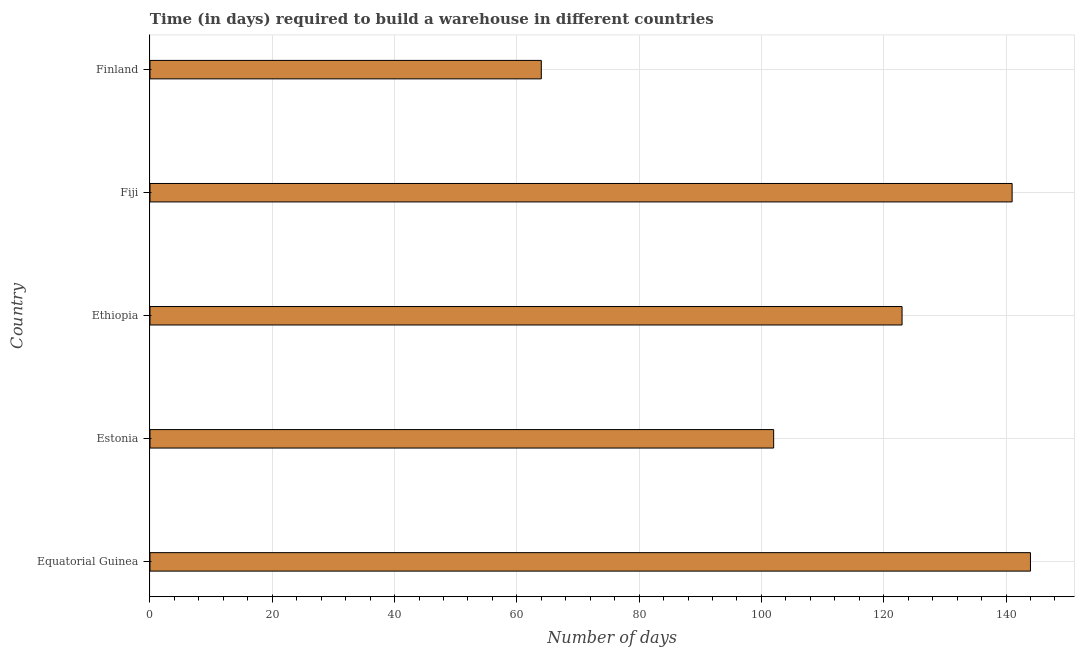Does the graph contain any zero values?
Offer a terse response. No. Does the graph contain grids?
Make the answer very short. Yes. What is the title of the graph?
Keep it short and to the point. Time (in days) required to build a warehouse in different countries. What is the label or title of the X-axis?
Ensure brevity in your answer.  Number of days. What is the label or title of the Y-axis?
Offer a terse response. Country. What is the time required to build a warehouse in Equatorial Guinea?
Offer a terse response. 144. Across all countries, what is the maximum time required to build a warehouse?
Your response must be concise. 144. In which country was the time required to build a warehouse maximum?
Offer a very short reply. Equatorial Guinea. What is the sum of the time required to build a warehouse?
Ensure brevity in your answer.  574. What is the average time required to build a warehouse per country?
Keep it short and to the point. 114.8. What is the median time required to build a warehouse?
Provide a short and direct response. 123. What is the ratio of the time required to build a warehouse in Estonia to that in Fiji?
Keep it short and to the point. 0.72. What is the difference between the highest and the lowest time required to build a warehouse?
Give a very brief answer. 80. How many bars are there?
Ensure brevity in your answer.  5. How many countries are there in the graph?
Give a very brief answer. 5. What is the difference between two consecutive major ticks on the X-axis?
Provide a short and direct response. 20. Are the values on the major ticks of X-axis written in scientific E-notation?
Offer a very short reply. No. What is the Number of days in Equatorial Guinea?
Offer a terse response. 144. What is the Number of days in Estonia?
Provide a succinct answer. 102. What is the Number of days of Ethiopia?
Your response must be concise. 123. What is the Number of days of Fiji?
Ensure brevity in your answer.  141. What is the Number of days in Finland?
Give a very brief answer. 64. What is the difference between the Number of days in Equatorial Guinea and Estonia?
Ensure brevity in your answer.  42. What is the difference between the Number of days in Equatorial Guinea and Fiji?
Ensure brevity in your answer.  3. What is the difference between the Number of days in Equatorial Guinea and Finland?
Offer a very short reply. 80. What is the difference between the Number of days in Estonia and Ethiopia?
Give a very brief answer. -21. What is the difference between the Number of days in Estonia and Fiji?
Offer a very short reply. -39. What is the difference between the Number of days in Ethiopia and Fiji?
Offer a very short reply. -18. What is the ratio of the Number of days in Equatorial Guinea to that in Estonia?
Keep it short and to the point. 1.41. What is the ratio of the Number of days in Equatorial Guinea to that in Ethiopia?
Your answer should be very brief. 1.17. What is the ratio of the Number of days in Equatorial Guinea to that in Finland?
Ensure brevity in your answer.  2.25. What is the ratio of the Number of days in Estonia to that in Ethiopia?
Ensure brevity in your answer.  0.83. What is the ratio of the Number of days in Estonia to that in Fiji?
Offer a very short reply. 0.72. What is the ratio of the Number of days in Estonia to that in Finland?
Offer a very short reply. 1.59. What is the ratio of the Number of days in Ethiopia to that in Fiji?
Your answer should be very brief. 0.87. What is the ratio of the Number of days in Ethiopia to that in Finland?
Provide a succinct answer. 1.92. What is the ratio of the Number of days in Fiji to that in Finland?
Give a very brief answer. 2.2. 